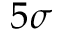<formula> <loc_0><loc_0><loc_500><loc_500>5 \sigma</formula> 